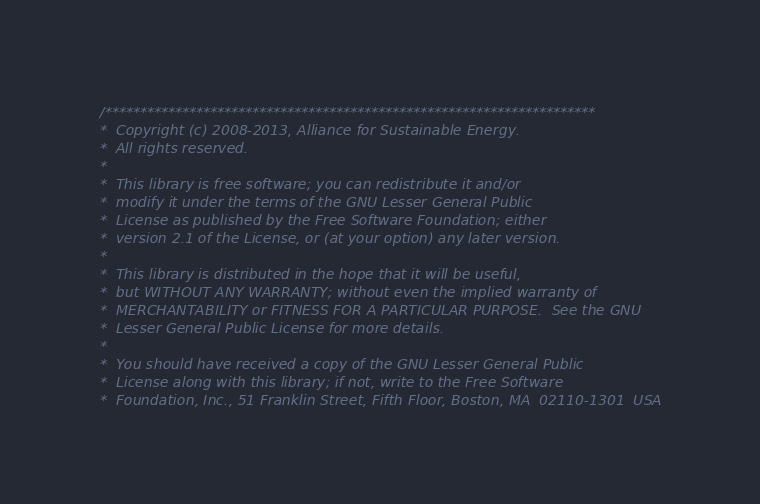Convert code to text. <code><loc_0><loc_0><loc_500><loc_500><_C++_>/**********************************************************************
*  Copyright (c) 2008-2013, Alliance for Sustainable Energy.
*  All rights reserved.
*  
*  This library is free software; you can redistribute it and/or
*  modify it under the terms of the GNU Lesser General Public
*  License as published by the Free Software Foundation; either
*  version 2.1 of the License, or (at your option) any later version.
*  
*  This library is distributed in the hope that it will be useful,
*  but WITHOUT ANY WARRANTY; without even the implied warranty of
*  MERCHANTABILITY or FITNESS FOR A PARTICULAR PURPOSE.  See the GNU
*  Lesser General Public License for more details.
*  
*  You should have received a copy of the GNU Lesser General Public
*  License along with this library; if not, write to the Free Software
*  Foundation, Inc., 51 Franklin Street, Fifth Floor, Boston, MA  02110-1301  USA</code> 